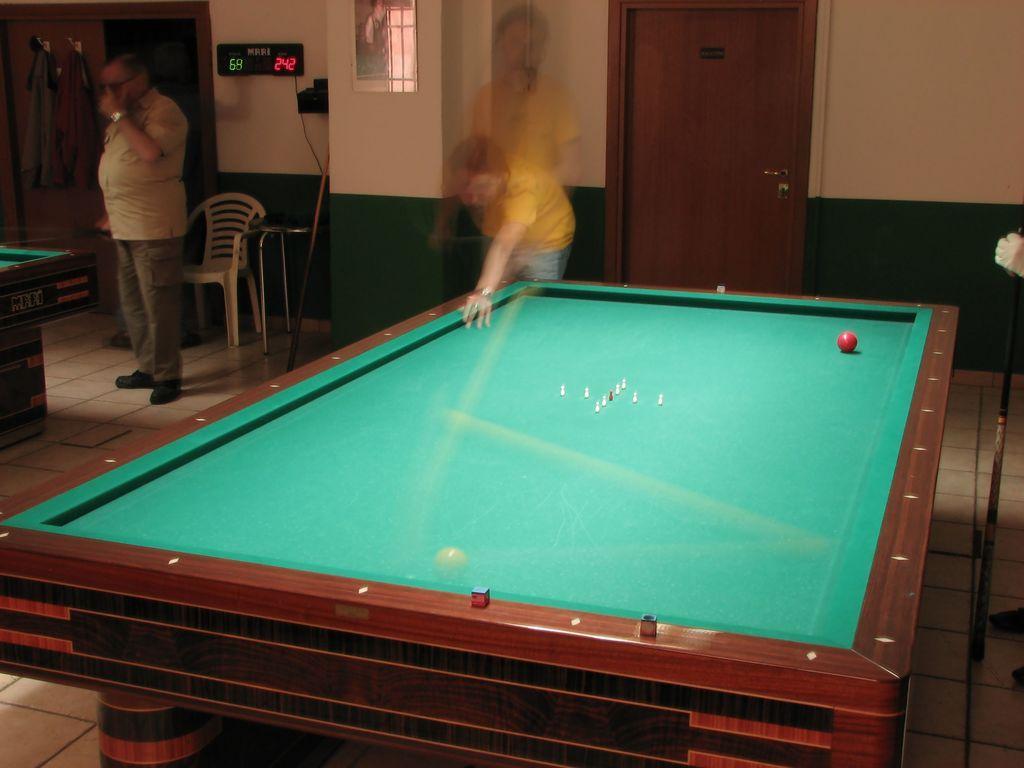Describe this image in one or two sentences. On the left a man is standing at a table. Behind him there is a chair and clothes hanging on the wall and a door. In the middle there is a board and the person is blur. 